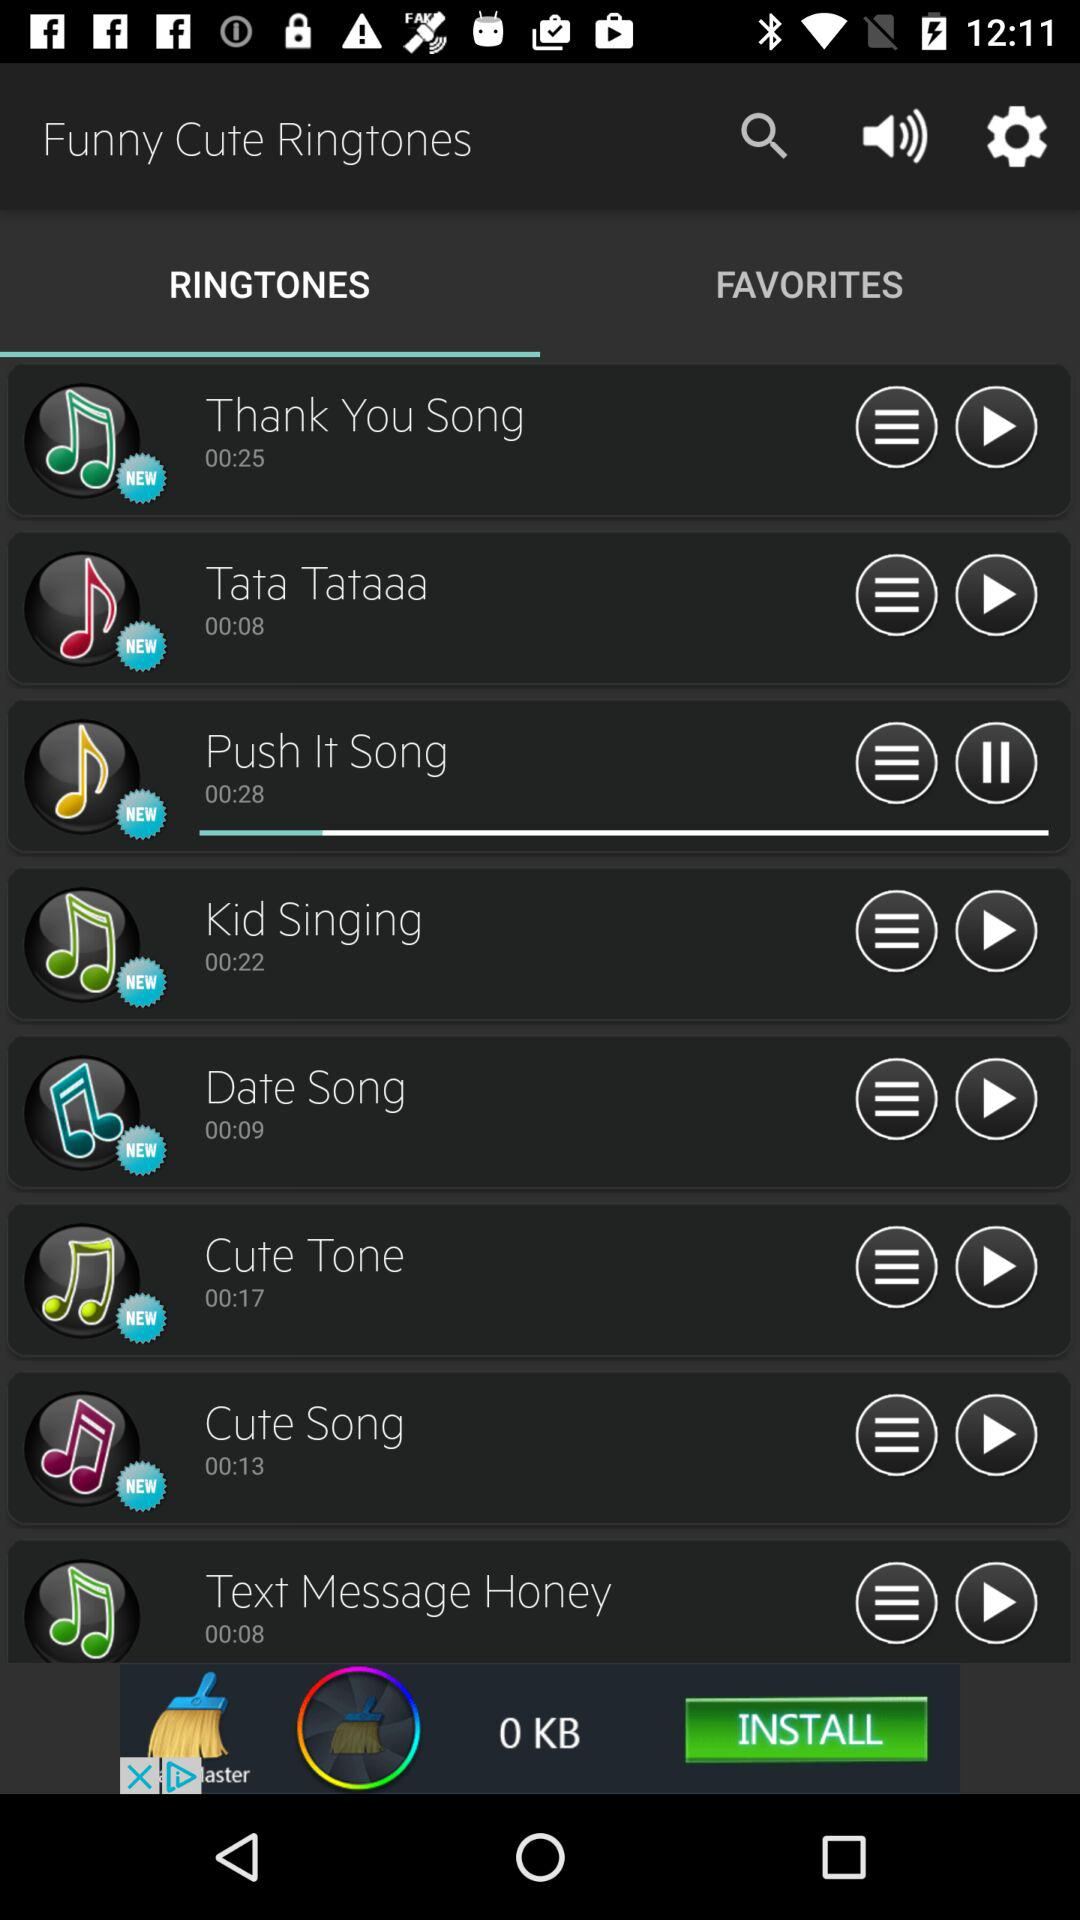Which tab is selected? The selected tab is "RINGTONES". 